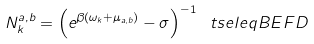Convert formula to latex. <formula><loc_0><loc_0><loc_500><loc_500>N ^ { a , b } _ { k } = \left ( e ^ { \beta ( \omega _ { k } + \mu _ { a , b } ) } - \sigma \right ) ^ { - 1 } \ t s e l e q { B E F D }</formula> 